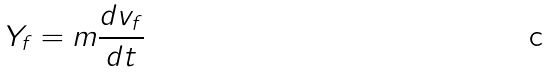<formula> <loc_0><loc_0><loc_500><loc_500>Y _ { f } = m \frac { d v _ { f } } { d t }</formula> 